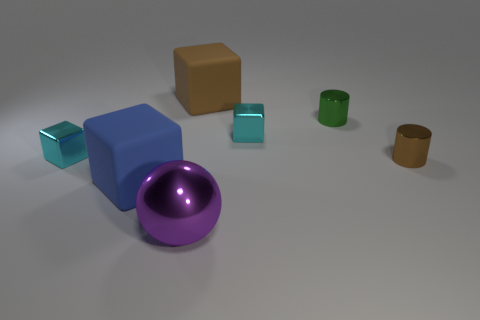There is a brown object that is made of the same material as the green cylinder; what shape is it?
Give a very brief answer. Cylinder. What number of other things are the same shape as the big purple shiny object?
Your answer should be compact. 0. There is a cyan metal block on the left side of the blue matte object; is it the same size as the blue rubber block?
Make the answer very short. No. Are there more green things behind the big blue object than purple cylinders?
Provide a short and direct response. Yes. There is a metallic block left of the blue object; how many tiny brown shiny objects are right of it?
Your answer should be compact. 1. Is the number of rubber objects that are to the right of the tiny brown cylinder less than the number of big cyan rubber balls?
Your answer should be very brief. No. There is a small green cylinder that is right of the big object behind the large blue object; is there a purple metal thing right of it?
Make the answer very short. No. Are the tiny brown thing and the brown object that is behind the brown metal thing made of the same material?
Your answer should be compact. No. The small shiny thing that is to the right of the tiny metal cylinder that is behind the tiny brown metal cylinder is what color?
Ensure brevity in your answer.  Brown. Is there a big cube that has the same color as the big sphere?
Ensure brevity in your answer.  No. 